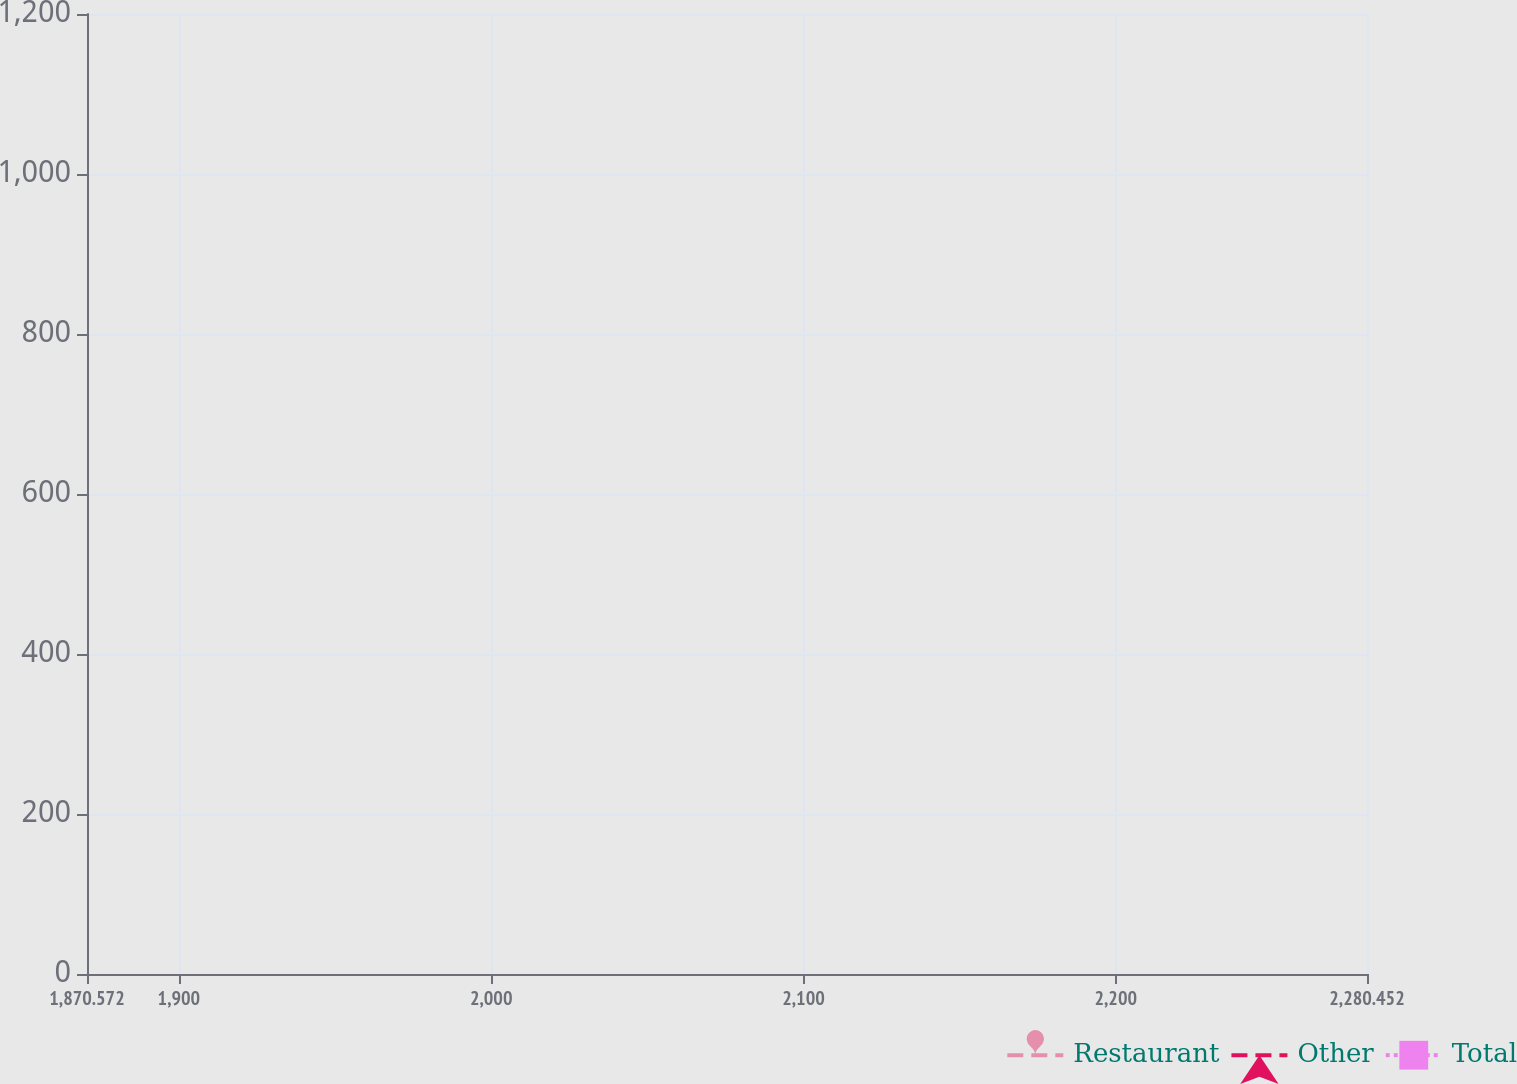Convert chart to OTSL. <chart><loc_0><loc_0><loc_500><loc_500><line_chart><ecel><fcel>Restaurant<fcel>Other<fcel>Total<nl><fcel>1911.56<fcel>928.07<fcel>64.01<fcel>1102.08<nl><fcel>2108.9<fcel>905.85<fcel>68.24<fcel>1149.99<nl><fcel>2178.08<fcel>692.72<fcel>43.75<fcel>808.82<nl><fcel>2281.57<fcel>824.51<fcel>39.52<fcel>964.7<nl><fcel>2321.44<fcel>714.94<fcel>24.2<fcel>639.21<nl></chart> 